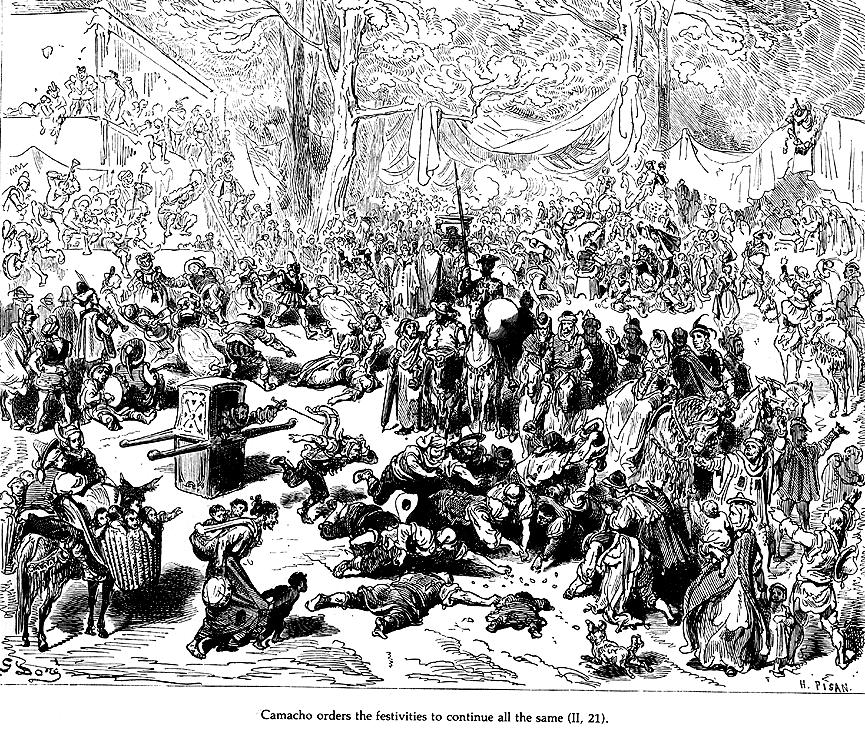What details in the illustration show differences in social status? The illustration meticulously highlights social distinctions through the attire and positions of the figures. Wealthier characters, like Camacho, are depicted with more elaborate and refined clothing, equipped with capes and armor, whereas the common folk exhibit simpler, more rudimentary attire. Placement also plays a role; influential figures are generally towards the center or elevated above the crowd, signifying their higher status and control. These visual cues subtly convey the hierarchical structure prevalent at the time. 